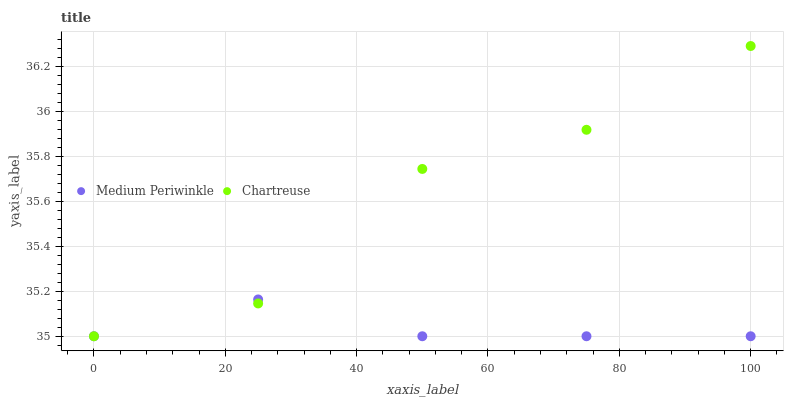Does Medium Periwinkle have the minimum area under the curve?
Answer yes or no. Yes. Does Chartreuse have the maximum area under the curve?
Answer yes or no. Yes. Does Medium Periwinkle have the maximum area under the curve?
Answer yes or no. No. Is Medium Periwinkle the smoothest?
Answer yes or no. Yes. Is Chartreuse the roughest?
Answer yes or no. Yes. Is Medium Periwinkle the roughest?
Answer yes or no. No. Does Chartreuse have the lowest value?
Answer yes or no. Yes. Does Chartreuse have the highest value?
Answer yes or no. Yes. Does Medium Periwinkle have the highest value?
Answer yes or no. No. Does Chartreuse intersect Medium Periwinkle?
Answer yes or no. Yes. Is Chartreuse less than Medium Periwinkle?
Answer yes or no. No. Is Chartreuse greater than Medium Periwinkle?
Answer yes or no. No. 